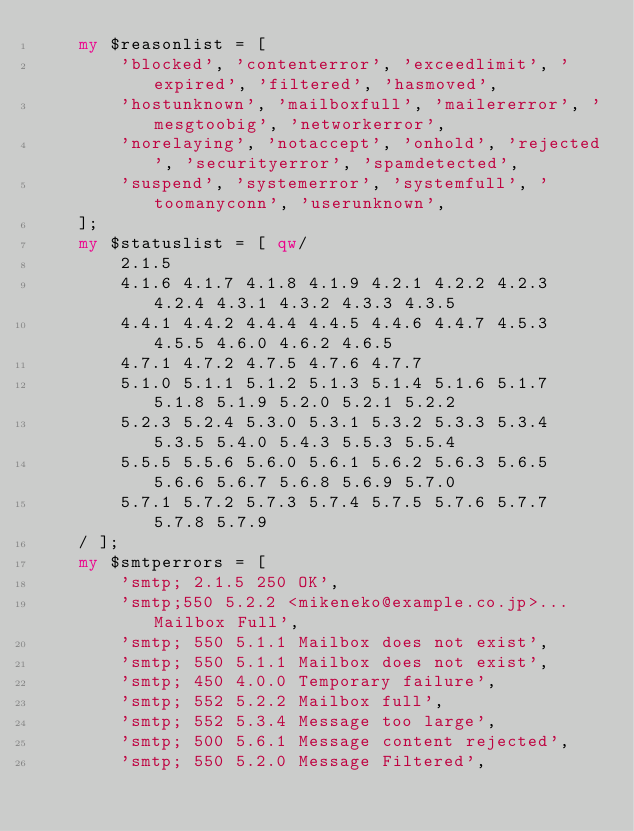<code> <loc_0><loc_0><loc_500><loc_500><_Perl_>    my $reasonlist = [ 
        'blocked', 'contenterror', 'exceedlimit', 'expired', 'filtered', 'hasmoved',
        'hostunknown', 'mailboxfull', 'mailererror', 'mesgtoobig', 'networkerror',
        'norelaying', 'notaccept', 'onhold', 'rejected', 'securityerror', 'spamdetected',
        'suspend', 'systemerror', 'systemfull', 'toomanyconn', 'userunknown',
    ];
    my $statuslist = [ qw/
        2.1.5
        4.1.6 4.1.7 4.1.8 4.1.9 4.2.1 4.2.2 4.2.3 4.2.4 4.3.1 4.3.2 4.3.3 4.3.5
        4.4.1 4.4.2 4.4.4 4.4.5 4.4.6 4.4.7 4.5.3 4.5.5 4.6.0 4.6.2 4.6.5
        4.7.1 4.7.2 4.7.5 4.7.6 4.7.7
        5.1.0 5.1.1 5.1.2 5.1.3 5.1.4 5.1.6 5.1.7 5.1.8 5.1.9 5.2.0 5.2.1 5.2.2
        5.2.3 5.2.4 5.3.0 5.3.1 5.3.2 5.3.3 5.3.4 5.3.5 5.4.0 5.4.3 5.5.3 5.5.4
        5.5.5 5.5.6 5.6.0 5.6.1 5.6.2 5.6.3 5.6.5 5.6.6 5.6.7 5.6.8 5.6.9 5.7.0
        5.7.1 5.7.2 5.7.3 5.7.4 5.7.5 5.7.6 5.7.7 5.7.8 5.7.9
    / ];
    my $smtperrors = [
        'smtp; 2.1.5 250 OK',
        'smtp;550 5.2.2 <mikeneko@example.co.jp>... Mailbox Full',
        'smtp; 550 5.1.1 Mailbox does not exist',
        'smtp; 550 5.1.1 Mailbox does not exist',
        'smtp; 450 4.0.0 Temporary failure',
        'smtp; 552 5.2.2 Mailbox full',
        'smtp; 552 5.3.4 Message too large',
        'smtp; 500 5.6.1 Message content rejected',
        'smtp; 550 5.2.0 Message Filtered',</code> 